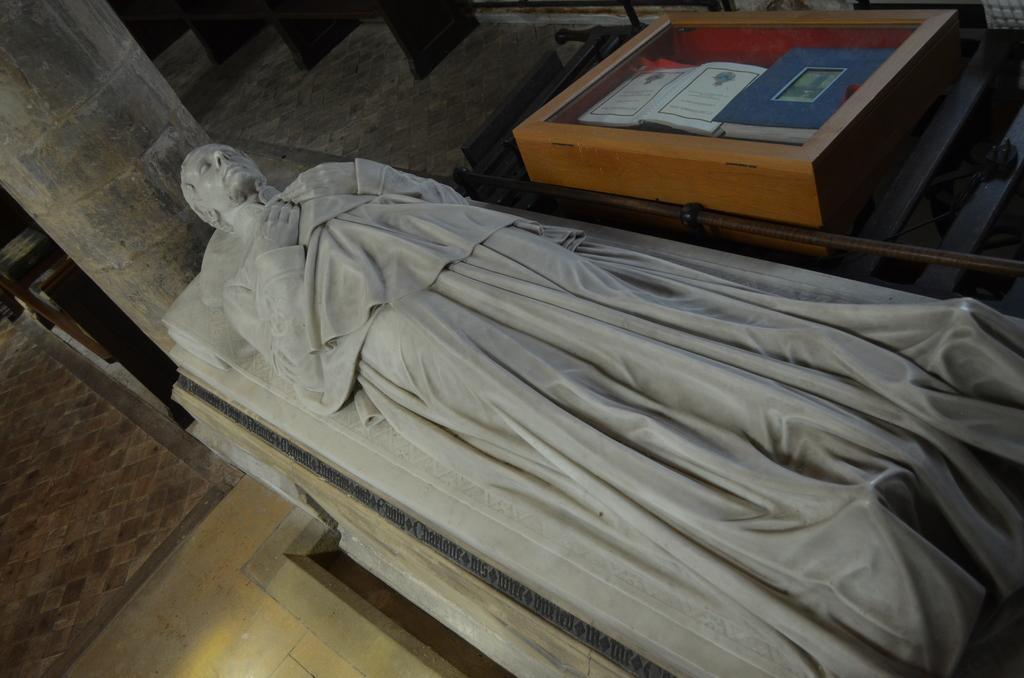Could you give a brief overview of what you see in this image? In this picture we can see a statue of a person, pillar, books in a box and some objects. 